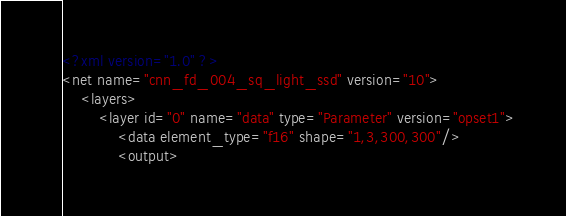<code> <loc_0><loc_0><loc_500><loc_500><_XML_><?xml version="1.0" ?>
<net name="cnn_fd_004_sq_light_ssd" version="10">
	<layers>
		<layer id="0" name="data" type="Parameter" version="opset1">
			<data element_type="f16" shape="1,3,300,300"/>
			<output></code> 